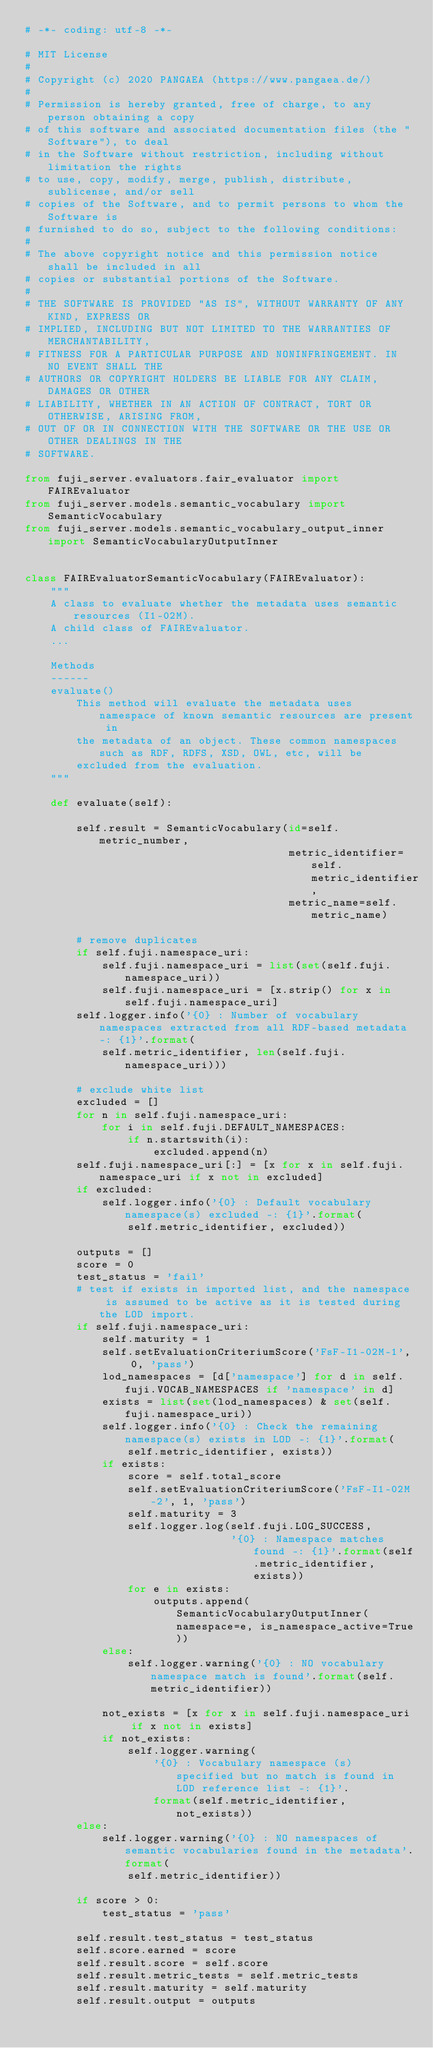<code> <loc_0><loc_0><loc_500><loc_500><_Python_># -*- coding: utf-8 -*-

# MIT License
#
# Copyright (c) 2020 PANGAEA (https://www.pangaea.de/)
#
# Permission is hereby granted, free of charge, to any person obtaining a copy
# of this software and associated documentation files (the "Software"), to deal
# in the Software without restriction, including without limitation the rights
# to use, copy, modify, merge, publish, distribute, sublicense, and/or sell
# copies of the Software, and to permit persons to whom the Software is
# furnished to do so, subject to the following conditions:
#
# The above copyright notice and this permission notice shall be included in all
# copies or substantial portions of the Software.
#
# THE SOFTWARE IS PROVIDED "AS IS", WITHOUT WARRANTY OF ANY KIND, EXPRESS OR
# IMPLIED, INCLUDING BUT NOT LIMITED TO THE WARRANTIES OF MERCHANTABILITY,
# FITNESS FOR A PARTICULAR PURPOSE AND NONINFRINGEMENT. IN NO EVENT SHALL THE
# AUTHORS OR COPYRIGHT HOLDERS BE LIABLE FOR ANY CLAIM, DAMAGES OR OTHER
# LIABILITY, WHETHER IN AN ACTION OF CONTRACT, TORT OR OTHERWISE, ARISING FROM,
# OUT OF OR IN CONNECTION WITH THE SOFTWARE OR THE USE OR OTHER DEALINGS IN THE
# SOFTWARE.

from fuji_server.evaluators.fair_evaluator import FAIREvaluator
from fuji_server.models.semantic_vocabulary import SemanticVocabulary
from fuji_server.models.semantic_vocabulary_output_inner import SemanticVocabularyOutputInner


class FAIREvaluatorSemanticVocabulary(FAIREvaluator):
    """
    A class to evaluate whether the metadata uses semantic resources (I1-02M).
    A child class of FAIREvaluator.
    ...

    Methods
    ------
    evaluate()
        This method will evaluate the metadata uses namespace of known semantic resources are present in
        the metadata of an object. These common namespaces such as RDF, RDFS, XSD, OWL, etc, will be
        excluded from the evaluation.
    """

    def evaluate(self):

        self.result = SemanticVocabulary(id=self.metric_number,
                                         metric_identifier=self.metric_identifier,
                                         metric_name=self.metric_name)

        # remove duplicates
        if self.fuji.namespace_uri:
            self.fuji.namespace_uri = list(set(self.fuji.namespace_uri))
            self.fuji.namespace_uri = [x.strip() for x in self.fuji.namespace_uri]
        self.logger.info('{0} : Number of vocabulary namespaces extracted from all RDF-based metadata -: {1}'.format(
            self.metric_identifier, len(self.fuji.namespace_uri)))

        # exclude white list
        excluded = []
        for n in self.fuji.namespace_uri:
            for i in self.fuji.DEFAULT_NAMESPACES:
                if n.startswith(i):
                    excluded.append(n)
        self.fuji.namespace_uri[:] = [x for x in self.fuji.namespace_uri if x not in excluded]
        if excluded:
            self.logger.info('{0} : Default vocabulary namespace(s) excluded -: {1}'.format(
                self.metric_identifier, excluded))

        outputs = []
        score = 0
        test_status = 'fail'
        # test if exists in imported list, and the namespace is assumed to be active as it is tested during the LOD import.
        if self.fuji.namespace_uri:
            self.maturity = 1
            self.setEvaluationCriteriumScore('FsF-I1-02M-1', 0, 'pass')
            lod_namespaces = [d['namespace'] for d in self.fuji.VOCAB_NAMESPACES if 'namespace' in d]
            exists = list(set(lod_namespaces) & set(self.fuji.namespace_uri))
            self.logger.info('{0} : Check the remaining namespace(s) exists in LOD -: {1}'.format(
                self.metric_identifier, exists))
            if exists:
                score = self.total_score
                self.setEvaluationCriteriumScore('FsF-I1-02M-2', 1, 'pass')
                self.maturity = 3
                self.logger.log(self.fuji.LOG_SUCCESS,
                                '{0} : Namespace matches found -: {1}'.format(self.metric_identifier, exists))
                for e in exists:
                    outputs.append(SemanticVocabularyOutputInner(namespace=e, is_namespace_active=True))
            else:
                self.logger.warning('{0} : NO vocabulary namespace match is found'.format(self.metric_identifier))

            not_exists = [x for x in self.fuji.namespace_uri if x not in exists]
            if not_exists:
                self.logger.warning(
                    '{0} : Vocabulary namespace (s) specified but no match is found in LOD reference list -: {1}'.
                    format(self.metric_identifier, not_exists))
        else:
            self.logger.warning('{0} : NO namespaces of semantic vocabularies found in the metadata'.format(
                self.metric_identifier))

        if score > 0:
            test_status = 'pass'

        self.result.test_status = test_status
        self.score.earned = score
        self.result.score = self.score
        self.result.metric_tests = self.metric_tests
        self.result.maturity = self.maturity
        self.result.output = outputs
</code> 